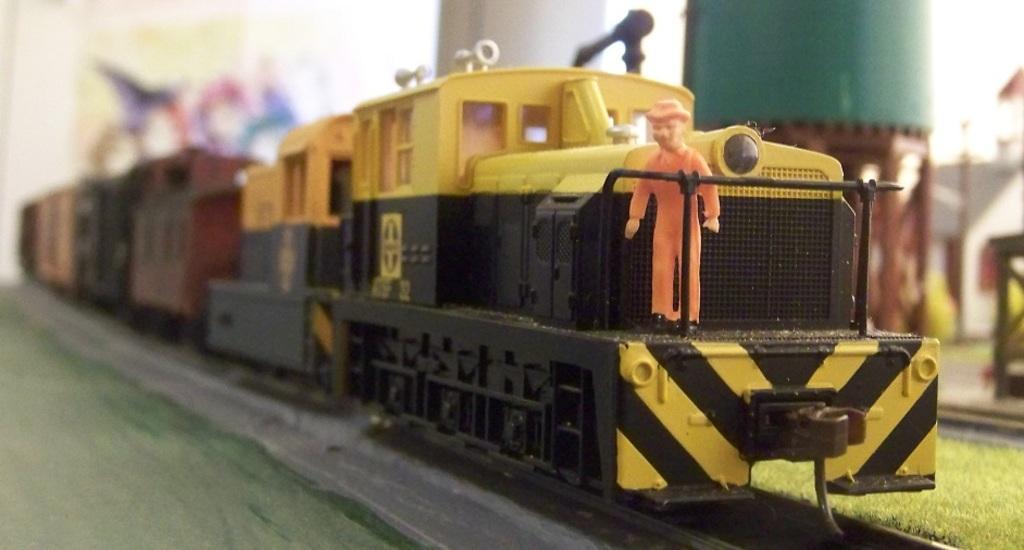Can you describe this image briefly? In this picture I can see there is a train on the track and it is in yellow color and there is a man standing and in the backdrop there is a pillar. 